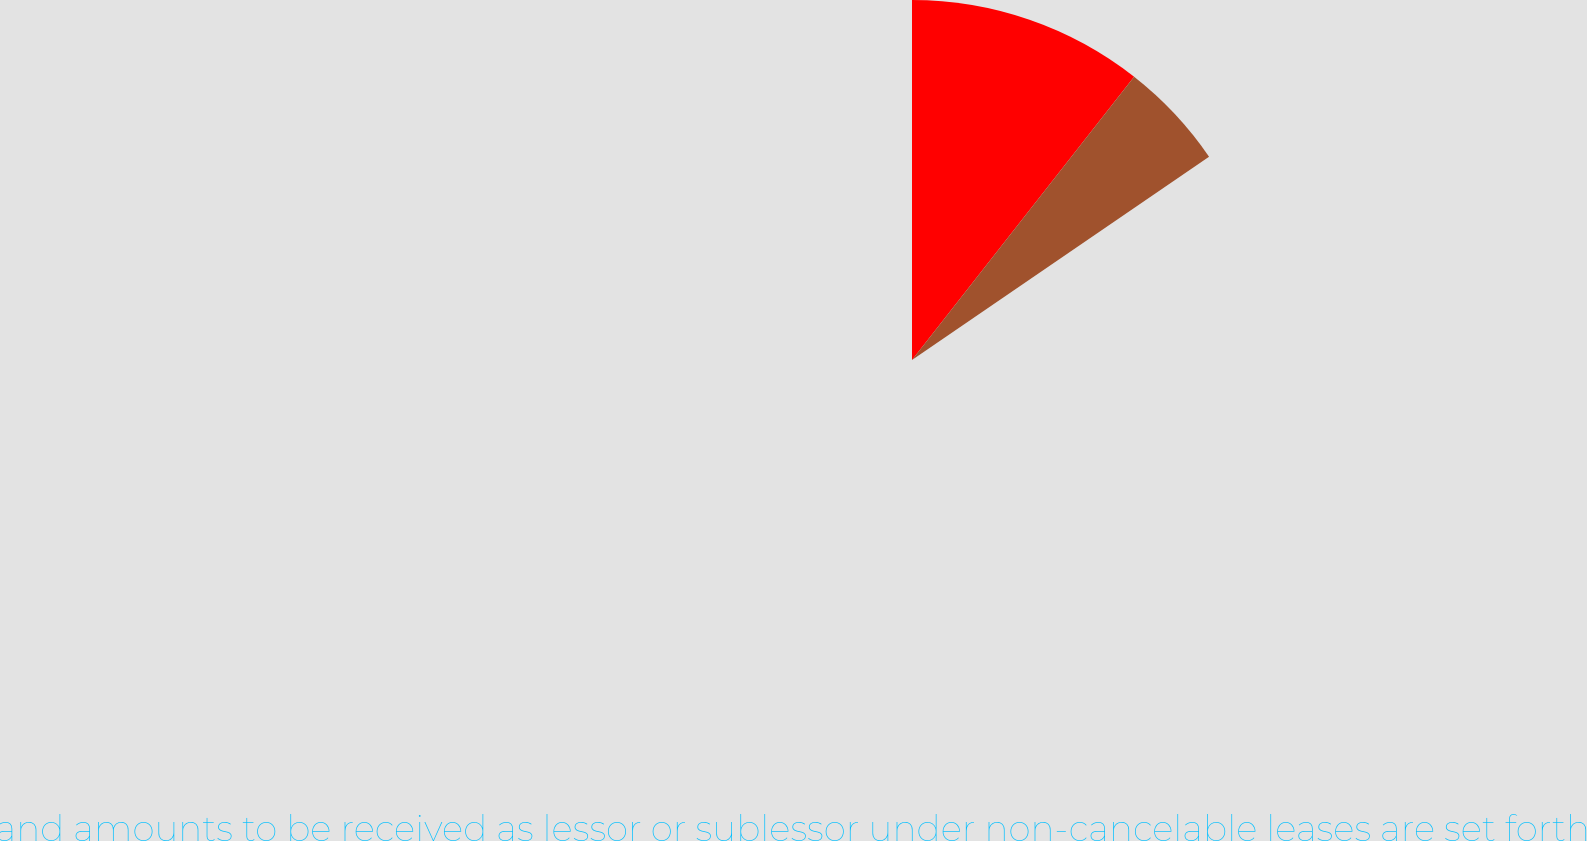<chart> <loc_0><loc_0><loc_500><loc_500><pie_chart><ecel><fcel>Future minimum commitments and amounts to be received as lessor or sublessor under non-cancelable leases are set forth<nl><fcel>68.52%<fcel>31.48%<nl></chart> 